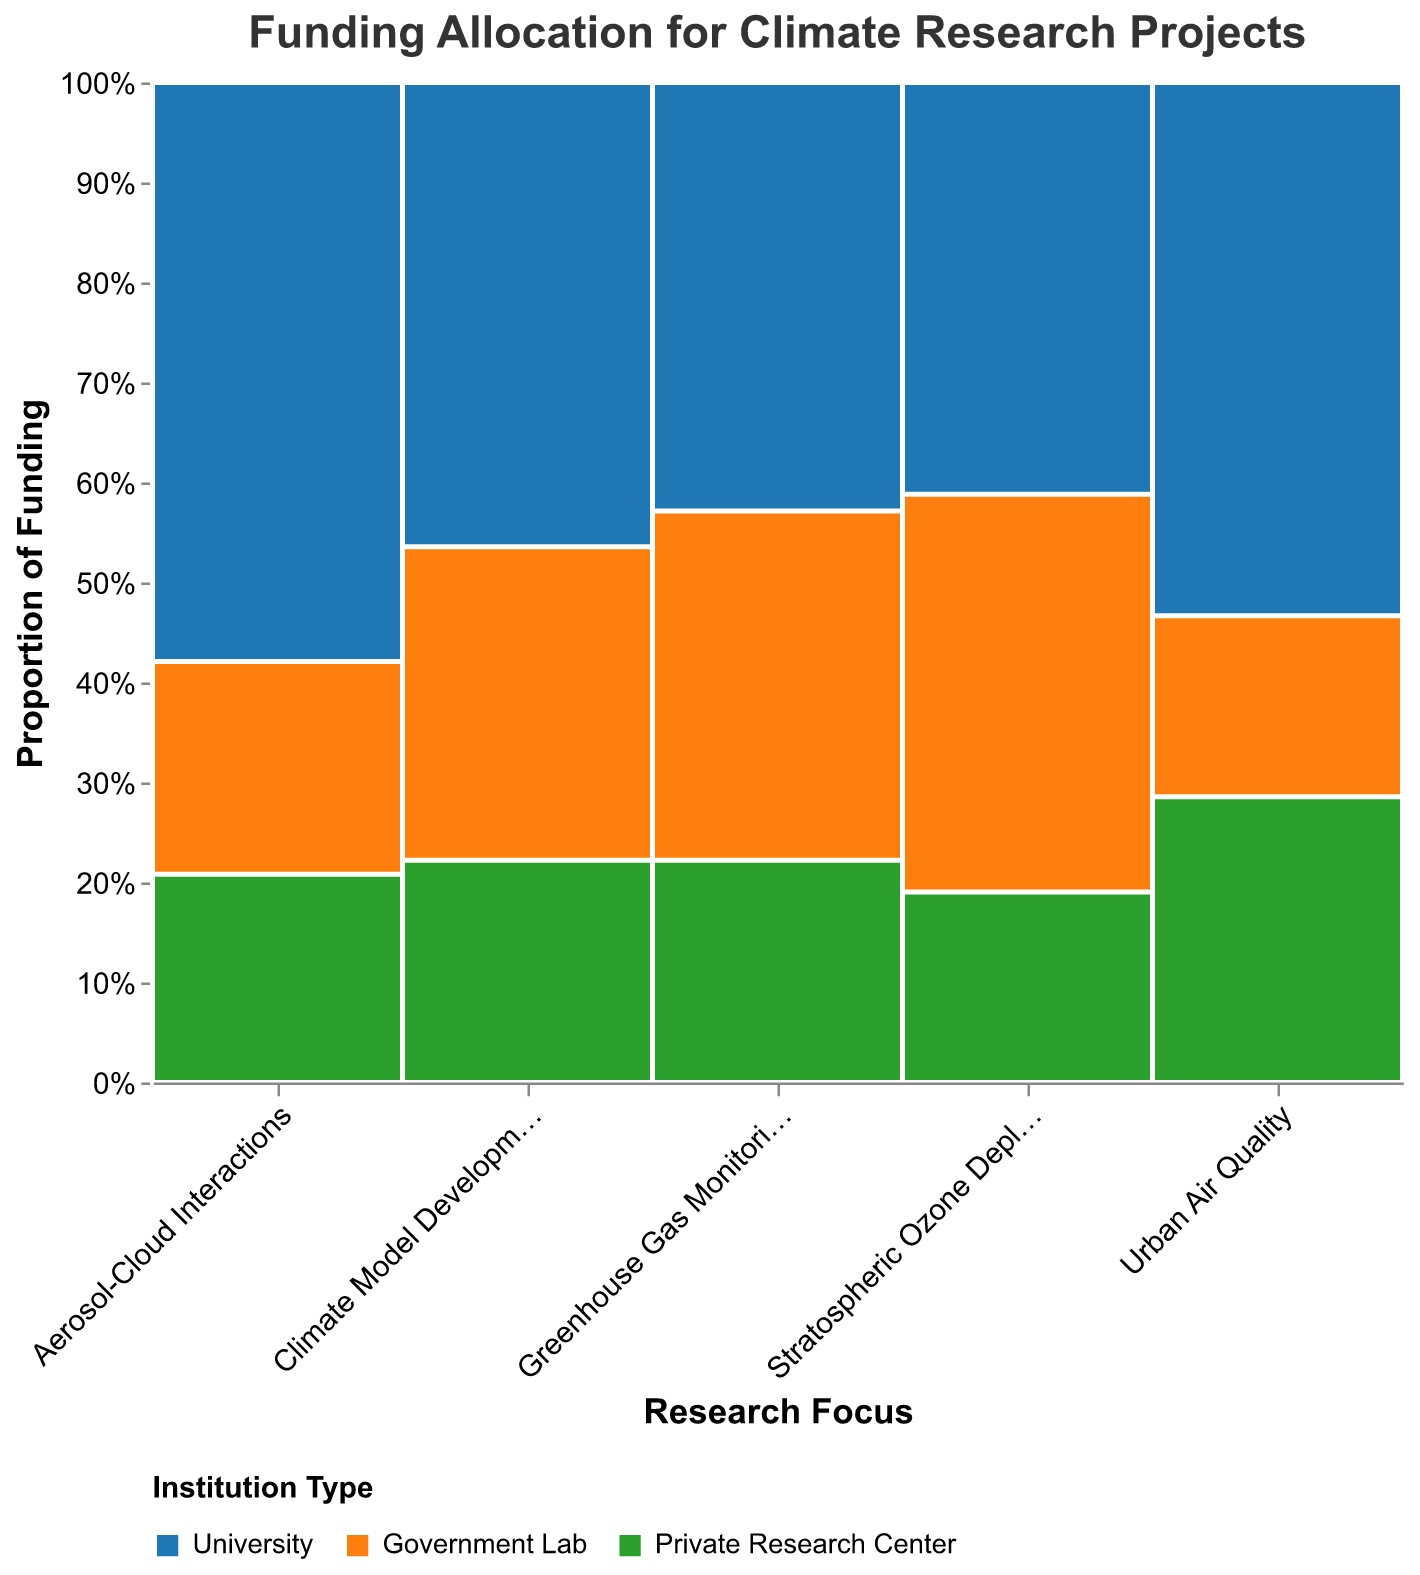What is the total funding allocated to Greenhouse Gas Monitoring projects? To find the total funding for Greenhouse Gas Monitoring, look at the sum of funding from University, Government Lab, and Private Research Center for this research focus. You can refer to the tooltip information in the mosaic plot.
Answer: 135 million USD Which research focus received the highest total funding? Compare the total funding for each research focus by adding up the contributions from University, Government Lab, and Private Research Center. The mosaic plot's visual height for each research focus can help identify the highest one.
Answer: Climate Model Development What is the proportion of funding for Universities within Climate Model Development? To find the proportion, look at the segment associated with Universities under Climate Model Development and check its tooltip. Then, divide University's funding (65 million USD) by the total funding for Climate Model Development (180 million USD).
Answer: 36.1% Which institution type received the most funding for Stratospheric Ozone Depletion research? Check each color segment for Stratospheric Ozone Depletion and see which segment is the largest. You can verify by inspecting the tooltip values for each institution.
Answer: Government Lab What is the difference in funding between Government Labs and Private Research Centers for Urban Air Quality projects? Look at the funding amounts for Government Labs (35 million USD) and Private Research Centers (30 million USD) under Urban Air Quality in their respective tooltips. Subtract the smaller amount from the larger amount.
Answer: 5 million USD Which research focus shows the most balanced funding distribution across institution types? By reviewing the plot, observe the segments for each research focus and note which focus has nearly equal-sized segments. Verify by comparing funding values within the tooltips for each institution type under the specific research focus.
Answer: Urban Air Quality How much more funding do Government Labs receive compared to Universities in Greenhouse Gas Monitoring research? Find the funding values for Government Labs (60 million USD) and Universities (45 million USD) from the tooltip in the Greenhouse Gas Monitoring section, and then subtract the University funding from the Government Lab funding.
Answer: 15 million USD Which institution type has the highest proportion of total funding for Aerosol-Cloud Interactions? In the plot section for Aerosol-Cloud Interactions, compare the relative heights of different colored segments (institution types). Verify with tooltips for exact proportions.
Answer: University What is the average funding received by Universities across all research focuses? Calculate the sum of funding for Universities across all research focuses (45 + 55 + 35 + 40 + 65) and then divide by the number of research focuses (5).
Answer: 48 million USD 